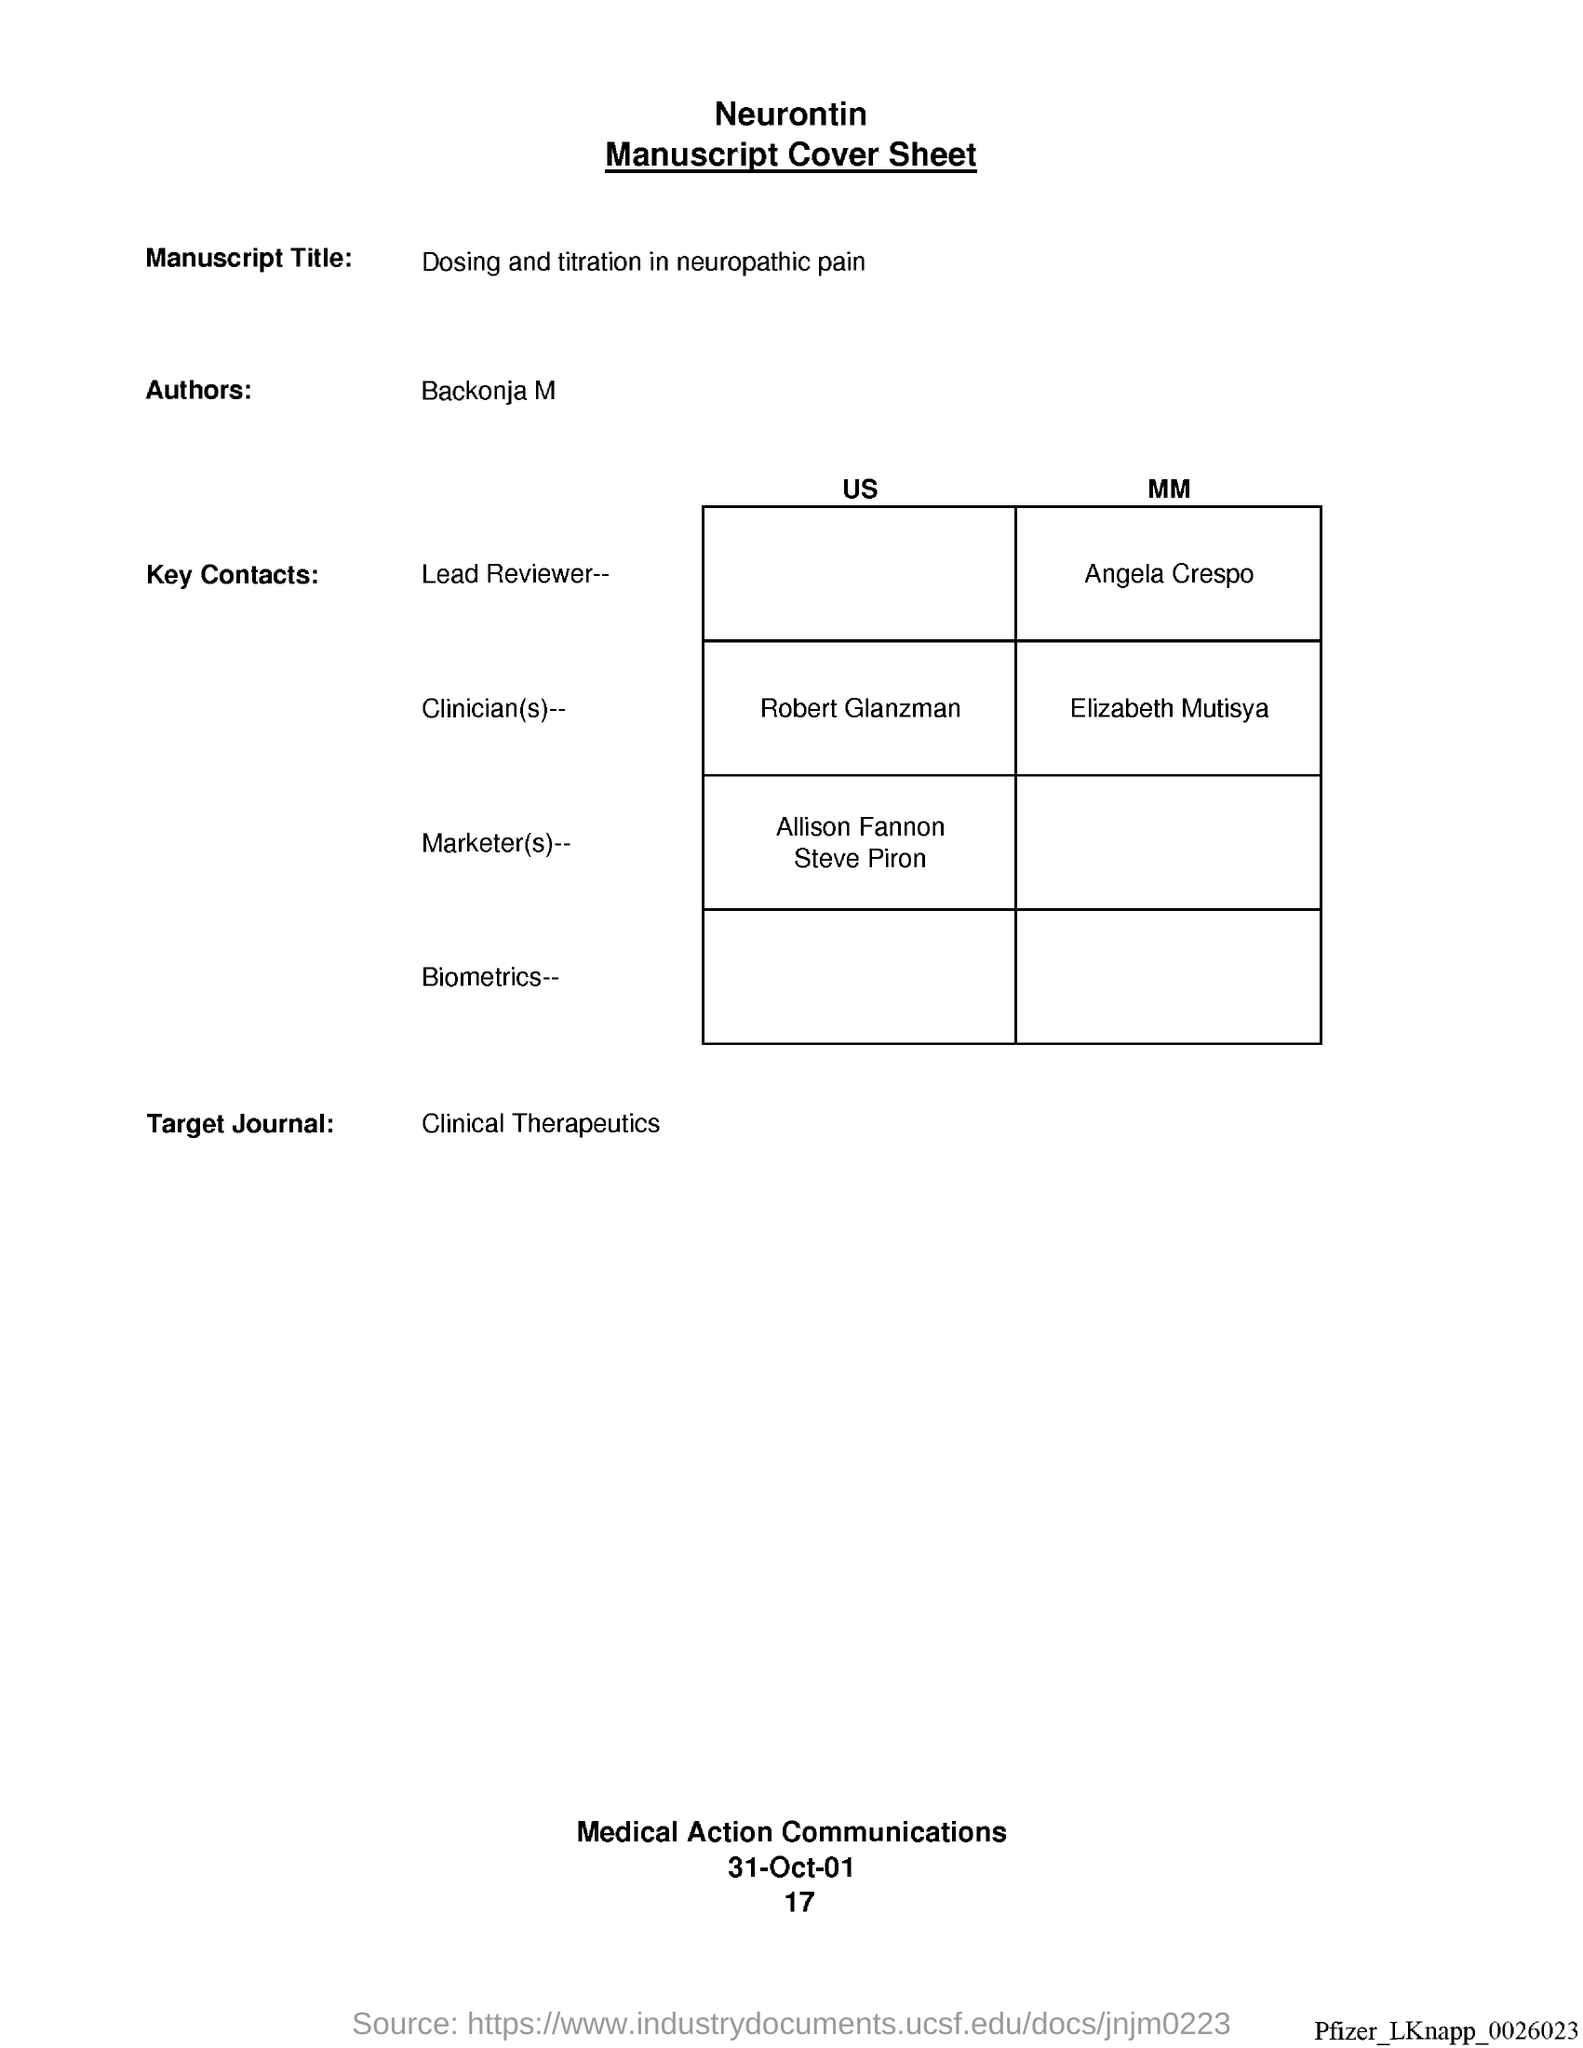What is the Manuscript Title?
Provide a succinct answer. Dosing and titration in neuropathic pain. What is the Target Journal?
Give a very brief answer. Clinical Therapeutics. Who is the Author?
Your response must be concise. Backonja M. 